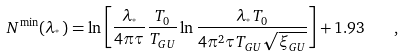Convert formula to latex. <formula><loc_0><loc_0><loc_500><loc_500>N ^ { \min } ( \lambda _ { ^ { * } } ) = \ln \left [ \frac { \lambda _ { ^ { * } } } { 4 \pi \tau } \frac { T _ { 0 } } { T _ { G U } } \ln \frac { \lambda _ { ^ { * } } T _ { 0 } } { 4 \pi ^ { 2 } \tau T _ { G U } \sqrt { \xi _ { G U } } } \right ] + 1 . 9 3 \quad ,</formula> 